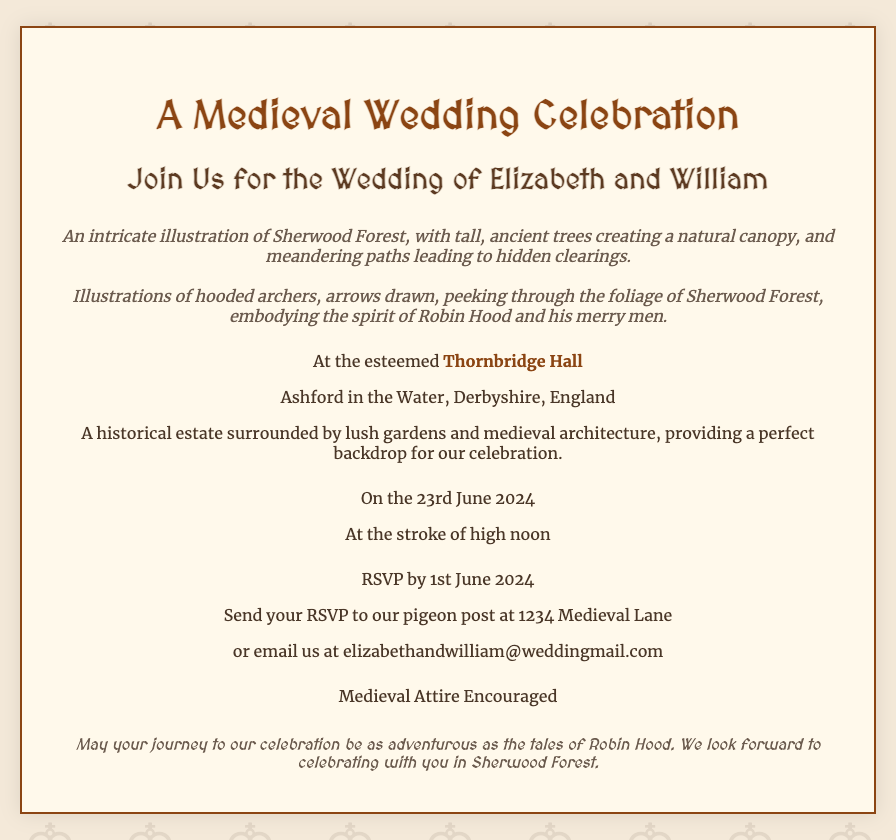What is the date of the wedding? The document states that the wedding is on the 23rd June 2024.
Answer: 23rd June 2024 What time does the wedding ceremony start? The document mentions that the ceremony starts at the stroke of high noon.
Answer: High noon Who are the couple getting married? The invitation names the couple as Elizabeth and William.
Answer: Elizabeth and William Where is the wedding venue located? The venue is at Thornbridge Hall in Ashford in the Water, Derbyshire, England.
Answer: Thornbridge Hall, Ashford in the Water, Derbyshire, England What is encouraged for attire at the wedding? The document requests that medieval attire is encouraged for the guests.
Answer: Medieval Attire What kind of illustrations are featured on the invitation? The invitation includes illustrations of Sherwood Forest and hooded archers.
Answer: Sherwood Forest and hooded archers What is the RSVP deadline? The document specifies that the RSVP should be sent by 1st June 2024.
Answer: 1st June 2024 How can guests send their RSVP? Guests can send their RSVP via pigeon post or email as mentioned in the document.
Answer: Pigeon post or email What is the theme of the invitation? The wedding invitation carries a medieval theme inspired by Robin Hood.
Answer: Medieval theme inspired by Robin Hood 